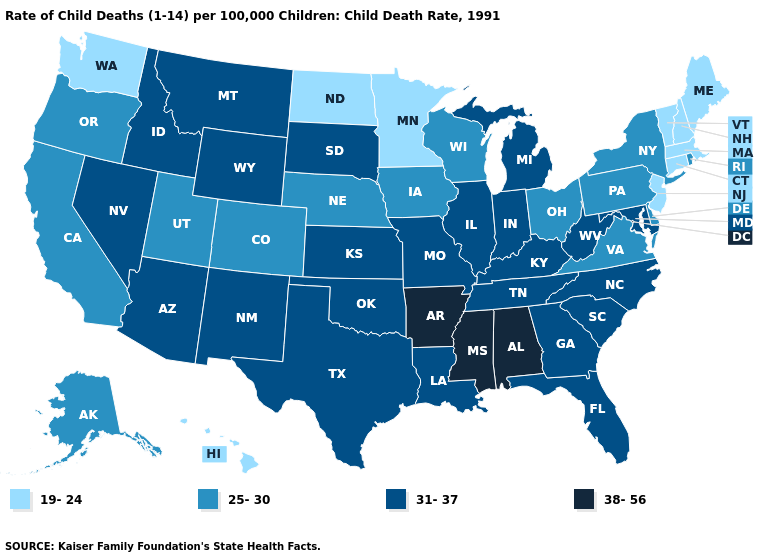Does Hawaii have a lower value than Iowa?
Be succinct. Yes. What is the value of Rhode Island?
Write a very short answer. 25-30. Name the states that have a value in the range 31-37?
Quick response, please. Arizona, Florida, Georgia, Idaho, Illinois, Indiana, Kansas, Kentucky, Louisiana, Maryland, Michigan, Missouri, Montana, Nevada, New Mexico, North Carolina, Oklahoma, South Carolina, South Dakota, Tennessee, Texas, West Virginia, Wyoming. What is the value of Texas?
Concise answer only. 31-37. Among the states that border South Dakota , which have the highest value?
Concise answer only. Montana, Wyoming. Does Ohio have a higher value than Connecticut?
Answer briefly. Yes. What is the highest value in the USA?
Be succinct. 38-56. How many symbols are there in the legend?
Give a very brief answer. 4. Does Washington have a higher value than Indiana?
Be succinct. No. Does Maryland have the highest value in the South?
Give a very brief answer. No. Does Arkansas have the highest value in the USA?
Quick response, please. Yes. Among the states that border Maryland , does Virginia have the lowest value?
Answer briefly. Yes. Does North Dakota have the highest value in the USA?
Keep it brief. No. Among the states that border Florida , does Alabama have the highest value?
Concise answer only. Yes. Among the states that border Vermont , which have the lowest value?
Quick response, please. Massachusetts, New Hampshire. 